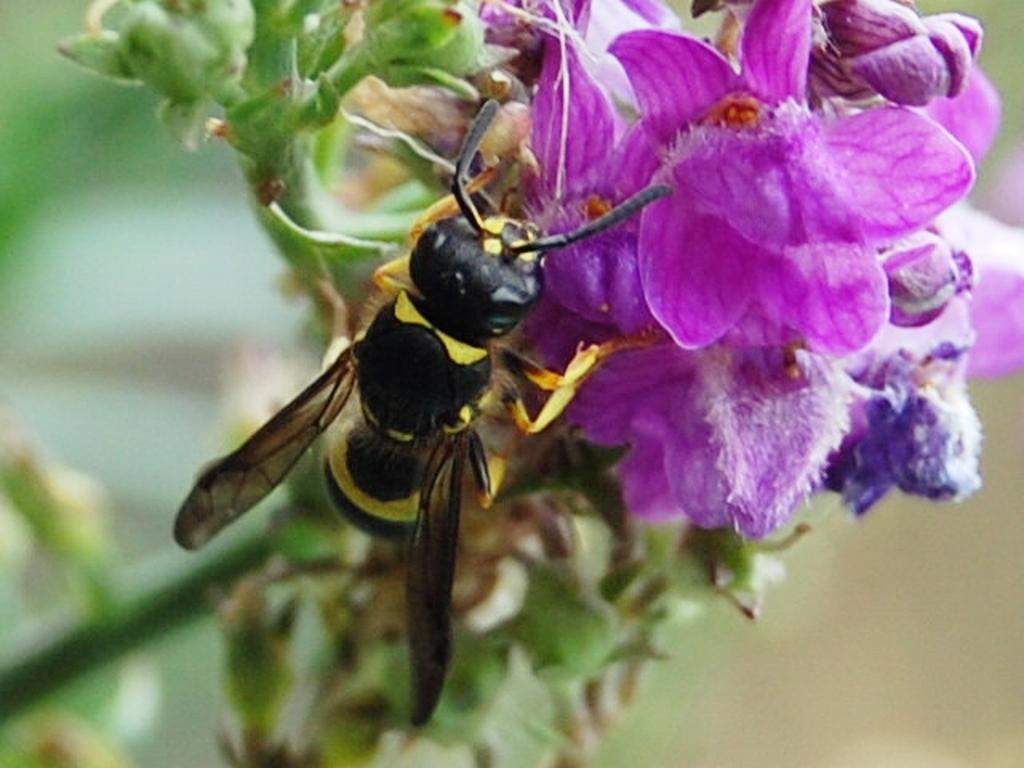What is present in the image? There is a fly in the image. Where is the fly located? The fly is on a flower. What is the main focus of the image? The flower is in the center of the image. How many dogs are visible in the image? There are no dogs present in the image. Is the fly crying in the image? Flies do not have the ability to cry, and there is no indication of crying in the image. 